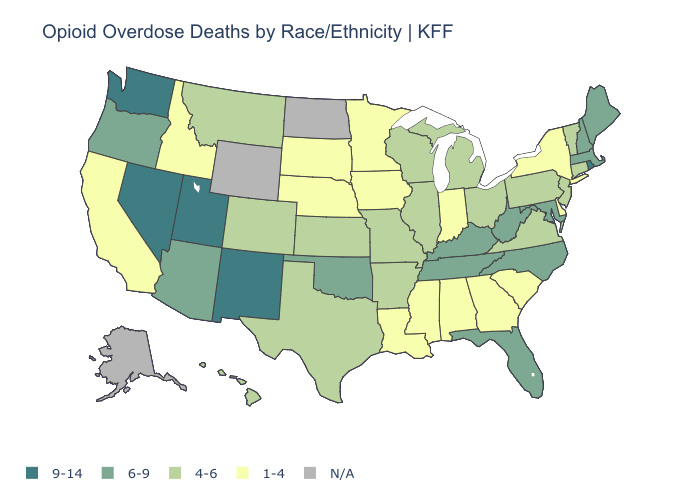What is the lowest value in the USA?
Write a very short answer. 1-4. Does Michigan have the highest value in the USA?
Be succinct. No. Does the map have missing data?
Answer briefly. Yes. Does Wisconsin have the highest value in the MidWest?
Answer briefly. Yes. What is the value of Wyoming?
Short answer required. N/A. Name the states that have a value in the range 4-6?
Give a very brief answer. Arkansas, Colorado, Connecticut, Hawaii, Illinois, Kansas, Michigan, Missouri, Montana, New Jersey, Ohio, Pennsylvania, Texas, Vermont, Virginia, Wisconsin. Does Montana have the highest value in the USA?
Be succinct. No. What is the value of Texas?
Keep it brief. 4-6. Name the states that have a value in the range 1-4?
Write a very short answer. Alabama, California, Delaware, Georgia, Idaho, Indiana, Iowa, Louisiana, Minnesota, Mississippi, Nebraska, New York, South Carolina, South Dakota. Among the states that border Arizona , does Colorado have the highest value?
Give a very brief answer. No. How many symbols are there in the legend?
Quick response, please. 5. Does Tennessee have the lowest value in the South?
Concise answer only. No. Does Mississippi have the lowest value in the USA?
Write a very short answer. Yes. Which states have the highest value in the USA?
Concise answer only. Nevada, New Mexico, Rhode Island, Utah, Washington. 